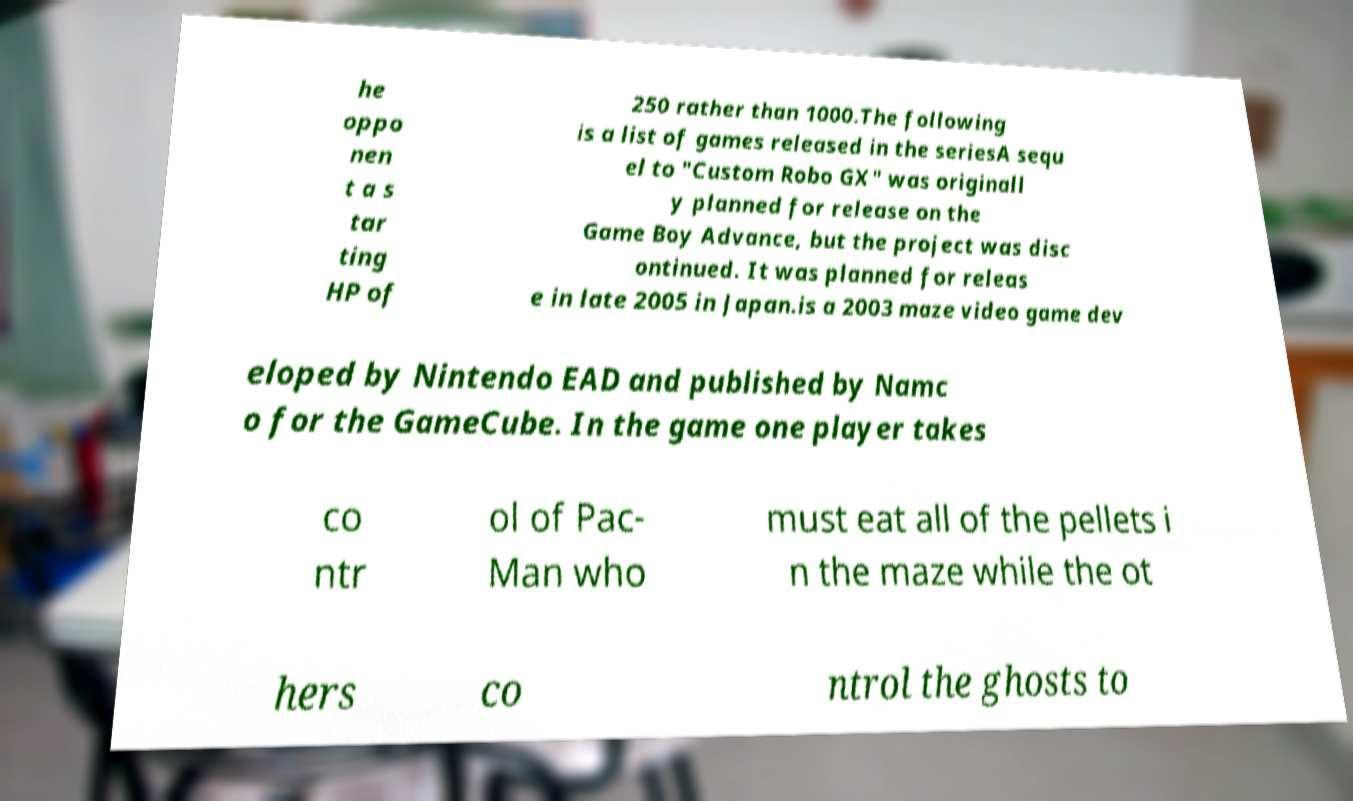Could you assist in decoding the text presented in this image and type it out clearly? he oppo nen t a s tar ting HP of 250 rather than 1000.The following is a list of games released in the seriesA sequ el to "Custom Robo GX" was originall y planned for release on the Game Boy Advance, but the project was disc ontinued. It was planned for releas e in late 2005 in Japan.is a 2003 maze video game dev eloped by Nintendo EAD and published by Namc o for the GameCube. In the game one player takes co ntr ol of Pac- Man who must eat all of the pellets i n the maze while the ot hers co ntrol the ghosts to 